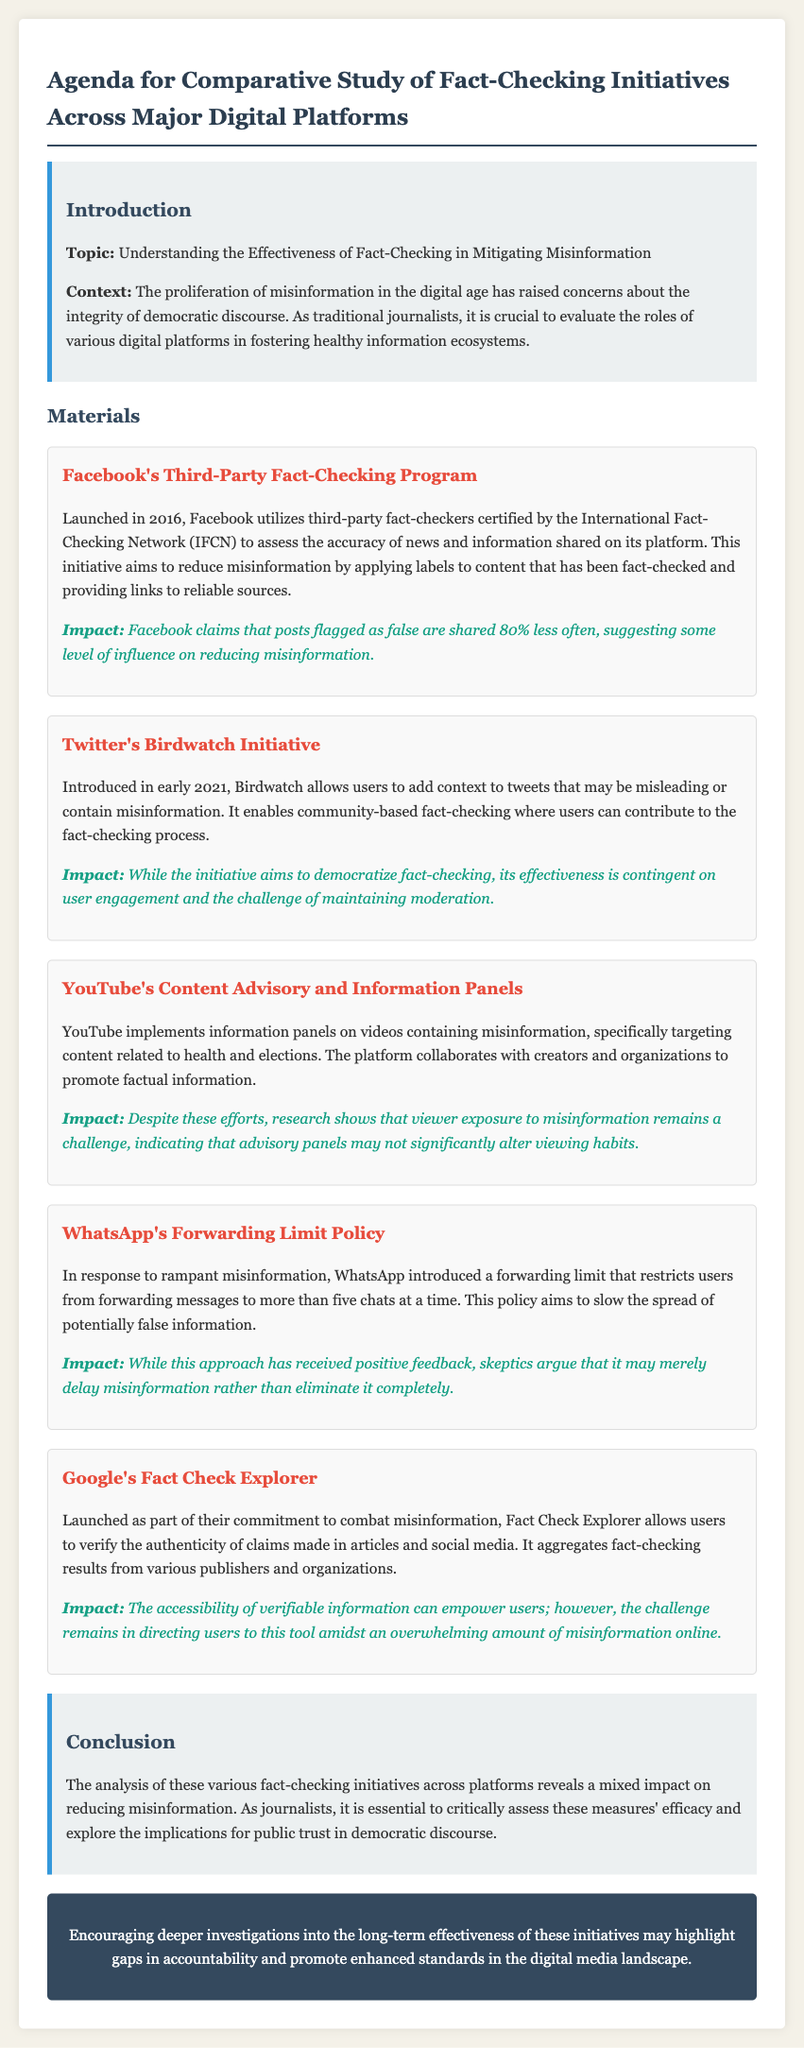what year did Facebook launch its fact-checking program? Facebook's Third-Party Fact-Checking Program was launched in 2016.
Answer: 2016 what is the main goal of Twitter's Birdwatch Initiative? Birdwatch allows users to add context to tweets that may be misleading or contain misinformation.
Answer: Context how does WhatsApp aim to slow the spread of misinformation? WhatsApp introduced a forwarding limit that restricts users from forwarding messages to more than five chats at a time.
Answer: Forwarding limit what is one noted impact of Facebook's fact-checking program? Facebook claims that posts flagged as false are shared 80% less often.
Answer: 80% less often which platform collaborates with creators and organizations to promote factual information? YouTube implements information panels on videos containing misinformation and collaborates with creators and organizations.
Answer: YouTube what is the primary function of Google's Fact Check Explorer? Fact Check Explorer allows users to verify the authenticity of claims made in articles and social media.
Answer: Verify authenticity what is the response to the effectiveness of YouTube's information panels? Research shows that viewer exposure to misinformation remains a challenge.
Answer: Challenge what is the concern raised by skeptics regarding WhatsApp's forwarding limit? Skeptics argue that it may merely delay misinformation rather than eliminate it completely.
Answer: Delay misinformation 